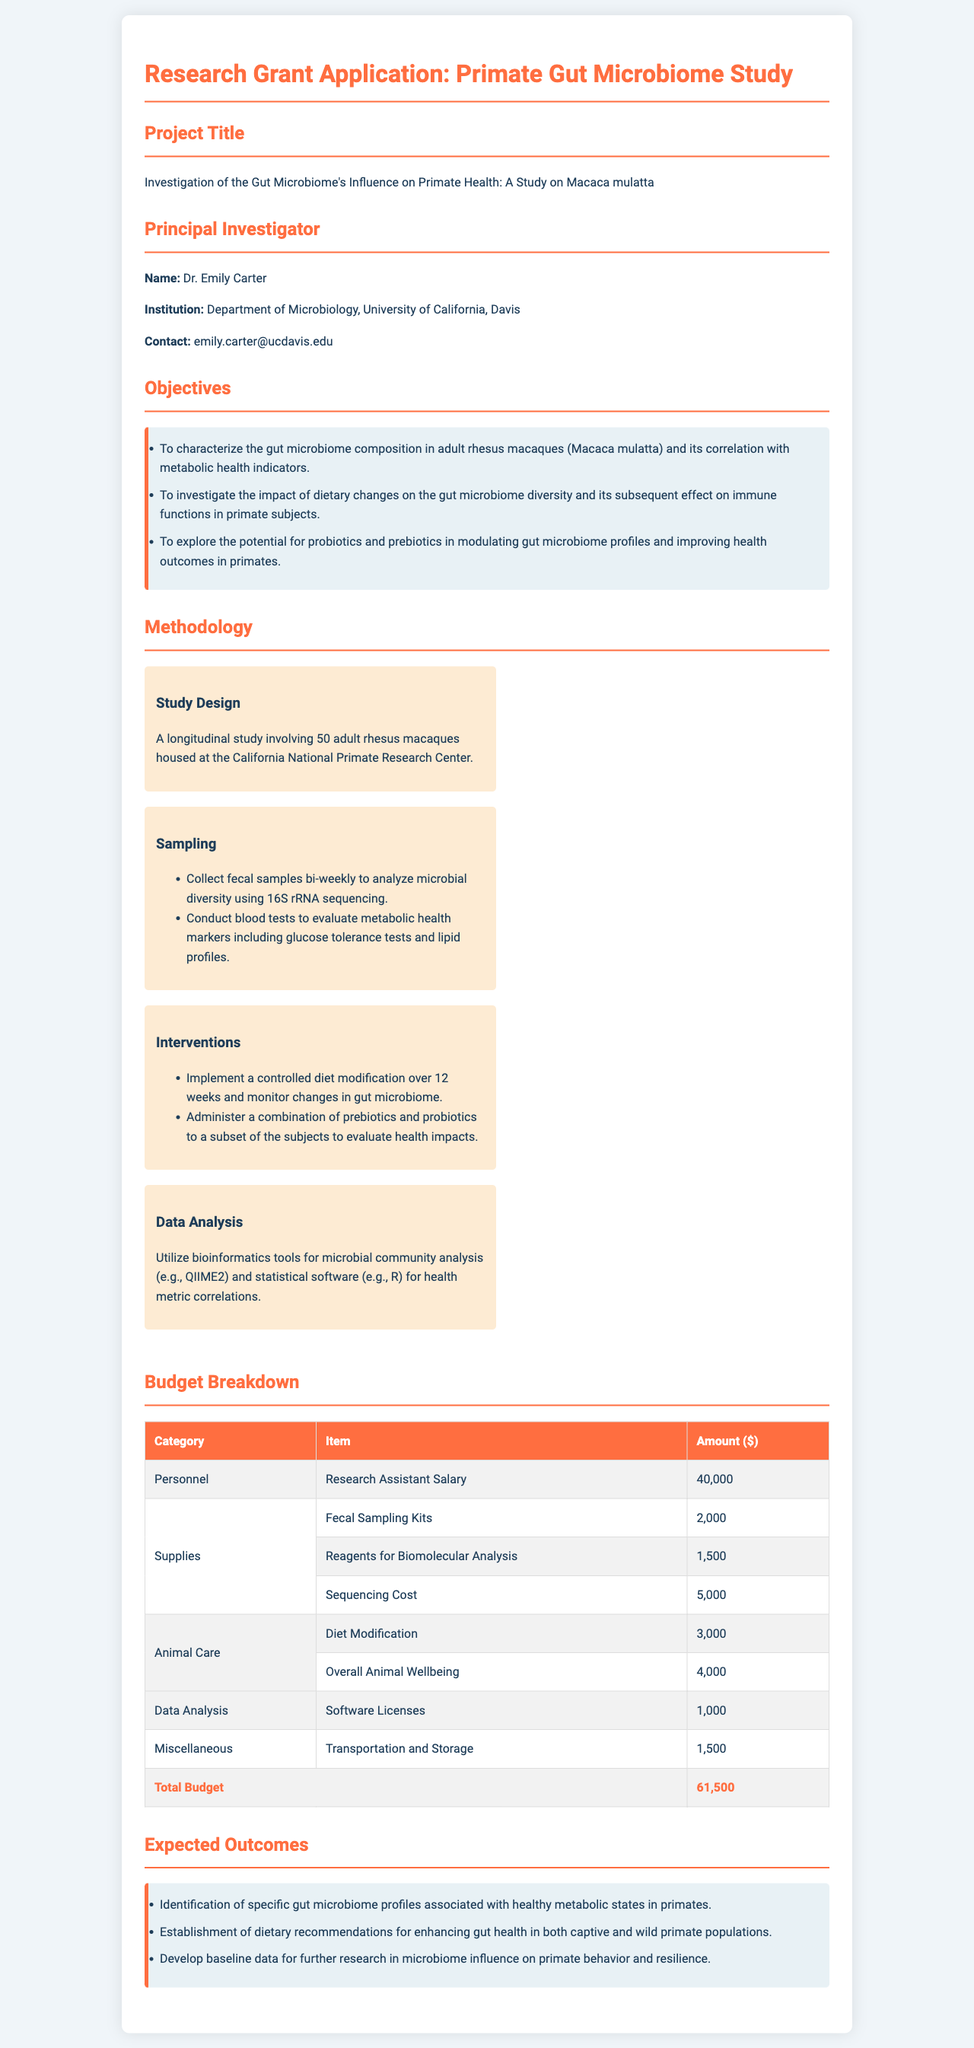What is the project title? The project title is explicitly stated in the document under "Project Title."
Answer: Investigation of the Gut Microbiome's Influence on Primate Health: A Study on Macaca mulatta Who is the principal investigator? The name of the principal investigator can be found in the "Principal Investigator" section of the document.
Answer: Dr. Emily Carter What is the total budget for the study? The total budget is summarized at the end of the "Budget Breakdown" section in the document.
Answer: 61,500 What is one of the objectives of the study? One of the objectives is listed in the "Objectives" section of the document.
Answer: To characterize the gut microbiome composition in adult rhesus macaques (Macaca mulatta) and its correlation with metabolic health indicators How many adult rhesus macaques are included in the study? This information can be found in the "Methodology" section, specifically under "Study Design."
Answer: 50 adult rhesus macaques What type of analysis will be used for microbial community analysis? The specific tool for microbial community analysis is mentioned in the "Data Analysis" subsection of "Methodology."
Answer: QIIME2 What are the supplies needed for fecal sampling? This information is detailed in the "Budget Breakdown" section under "Supplies."
Answer: Fecal Sampling Kits How long will the diet modification intervention last? The duration of the intervention is provided in the "Interventions" subsection of the "Methodology."
Answer: 12 weeks 